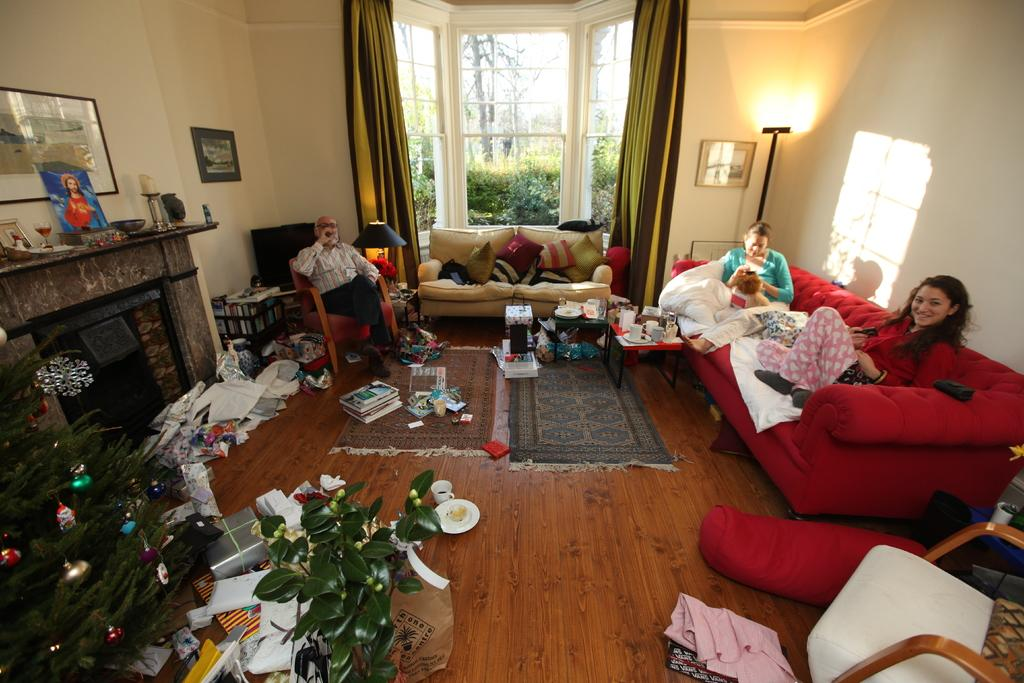What type of location is depicted in the image? The image shows an inner view of a house. How many people are present in the image? There are three people seated in the image. Can you identify any natural elements in the image? Yes, there is a plant visible in the image. What is hanging on the wall in the image? There is a photo frame on the wall in the image. What type of scarecrow is standing in the corner of the room in the image? There is no scarecrow present in the image; it is an inner view of a house with people and objects, but no scarecrow. What type of paper is covering the windows in the image? There is no paper covering the windows in the image; the windows are not mentioned in the provided facts. 